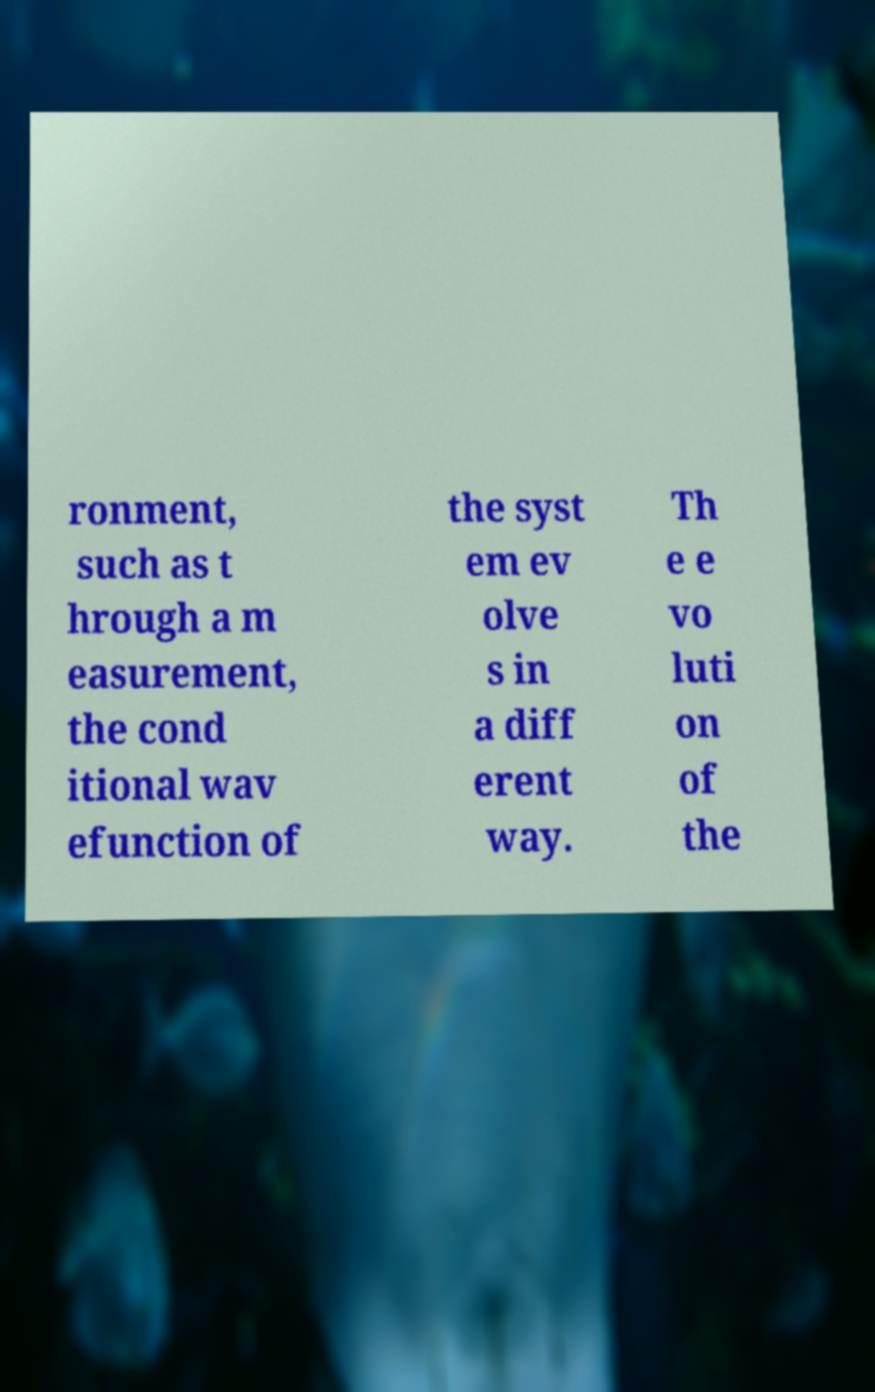What messages or text are displayed in this image? I need them in a readable, typed format. ronment, such as t hrough a m easurement, the cond itional wav efunction of the syst em ev olve s in a diff erent way. Th e e vo luti on of the 